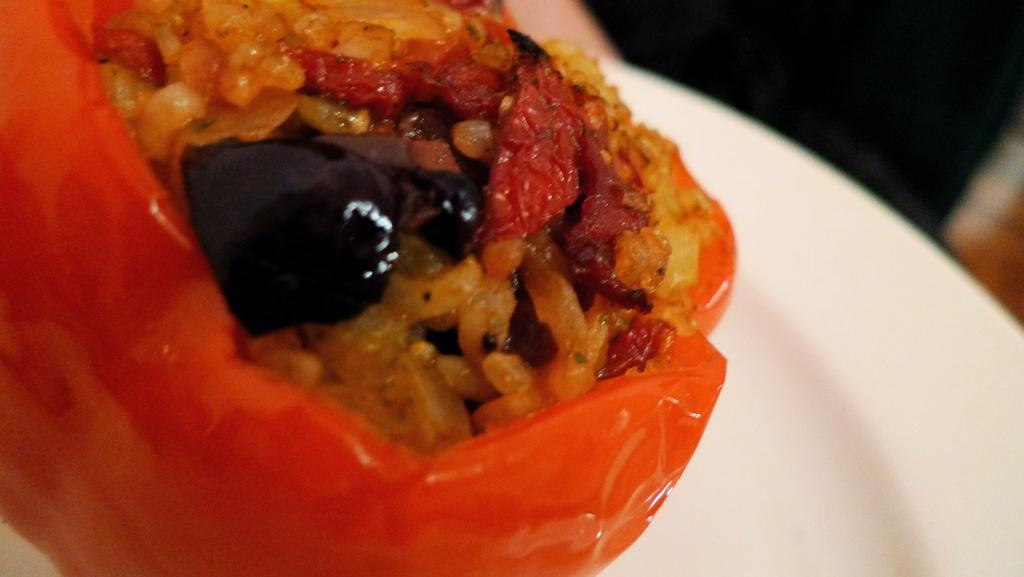What is on the white plate in the image? There is food on a white plate in the image. Can you describe the object at the top of the image? Unfortunately, the facts provided do not give enough information to describe the object at the top of the image. What is on the right side of the image? There is an object on the right side of the image. How would you describe the background of the image? The background of the image is blurred. What type of flower is growing on the earth in the image? There is no earth or flower present in the image. What type of print is visible on the food in the image? The facts provided do not mention any prints on the food in the image. 